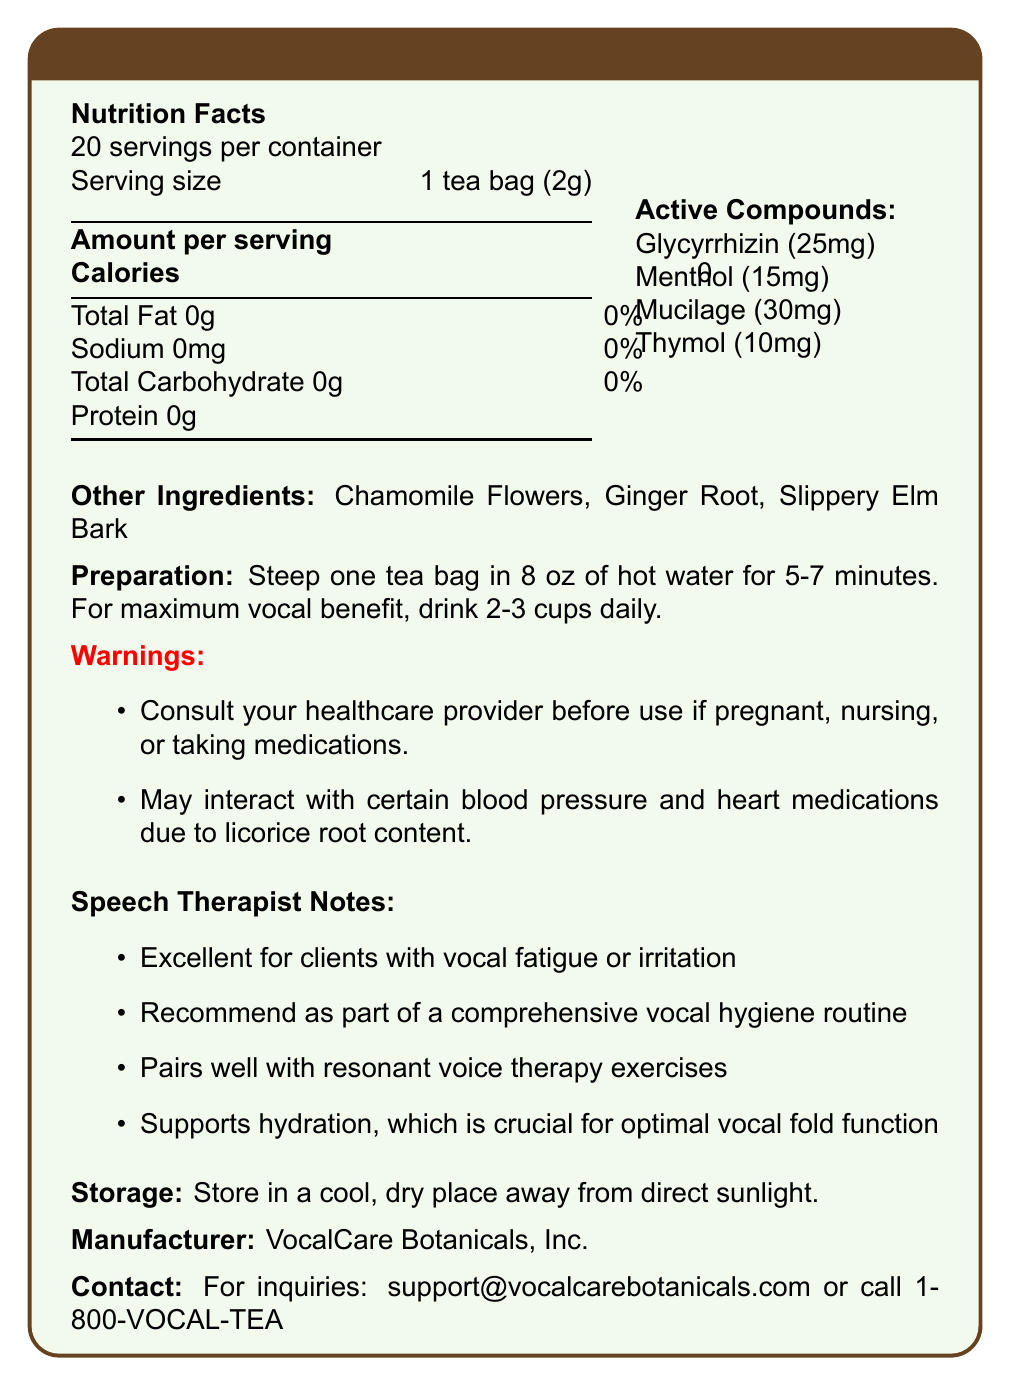What is the serving size for VocalEase Herbal Tea Blend? The document states that the serving size is 1 tea bag (2g).
Answer: 1 tea bag (2g) How many servings per container are provided? The document mentions that there are 20 servings per container.
Answer: 20 What are the calories per serving? The document lists the calories per serving as 0.
Answer: 0 Name two ingredients listed under active compounds. The document mentions Glycyrrhizin and Menthol as active compounds.
Answer: Glycyrrhizin, Menthol What is one of the speech therapist notes provided? The document provides a note stating that the tea is excellent for clients with vocal fatigue or irritation.
Answer: Excellent for clients with vocal fatigue or irritation What is the recommended daily intake for maximum vocal benefit? The preparation instructions advise drinking 2-3 cups daily for maximum vocal benefit.
Answer: 2-3 cups daily What should you consult your healthcare provider about before using this tea? A. If you are pregnant B. If you are nursing C. If you are taking medications D. All of the above The warnings section states to consult your healthcare provider if pregnant, nursing, or taking medications.
Answer: D. All of the above Which active compound is sourced from Thyme Leaves? A. Glycyrrhizin B. Menthol C. Mucilage D. Thymol The document specifies that Thymol is sourced from Thyme Leaves.
Answer: D. Thymol Do the tea bags contain any protein? The nutrition facts indicate that the tea contains 0g of protein.
Answer: No Is Glycyrrhizin's effect to provide a cooling sensation? Glycyrrhizin soothes throat irritation and reduces inflammation; Menthol provides the cooling sensation.
Answer: No Describe the overall purpose of the document. The document comprehensively presents all necessary information about the herbal tea blend to help users understand its benefits and usage.
Answer: The document provides detailed information about the VocalEase Herbal Tea Blend, including nutritional facts, active compounds and their effects, ingredient list, preparation instructions, warnings, and additional notes for speech therapists. How much mucilage is present in each serving of the tea? The active compounds section specifies that each serving contains 30mg of mucilage.
Answer: 30mg Where should the tea be stored? The storage instructions advise keeping the tea in a cool, dry place away from direct sunlight.
Answer: In a cool, dry place away from direct sunlight What is the manufacturer of this herbal tea blend? The document states that the manufacturer is VocalCare Botanicals, Inc.
Answer: VocalCare Botanicals, Inc. What is the email provided for inquiries? The contact information section provides the email support@vocalcarebotanicals.com for inquiries.
Answer: support@vocalcarebotanicals.com What blood pressure and heart medications might the tea interact with? The warnings mention that the tea may interact with certain blood pressure and heart medications but do not specify which ones.
Answer: Not enough information 